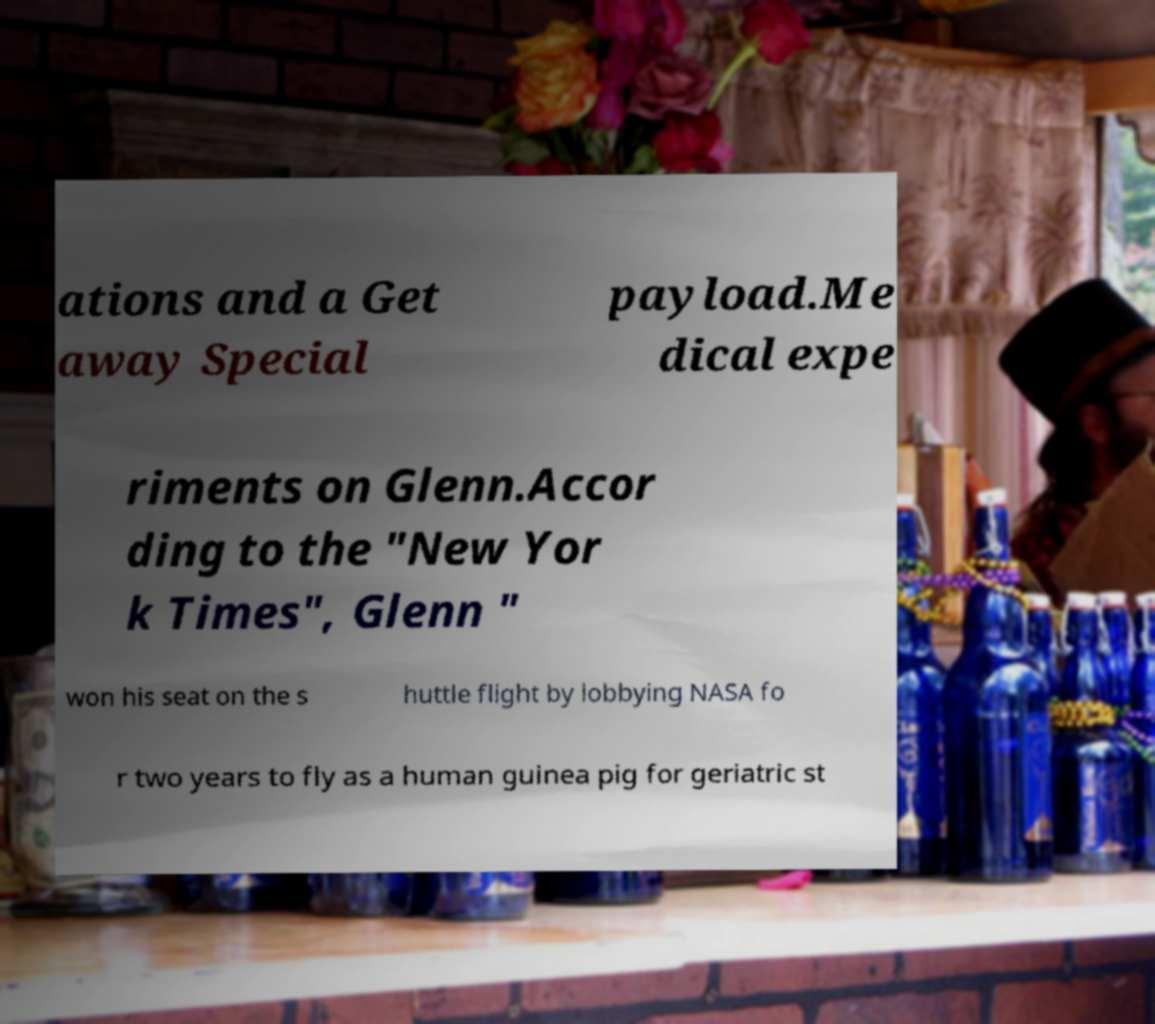Please identify and transcribe the text found in this image. ations and a Get away Special payload.Me dical expe riments on Glenn.Accor ding to the "New Yor k Times", Glenn " won his seat on the s huttle flight by lobbying NASA fo r two years to fly as a human guinea pig for geriatric st 